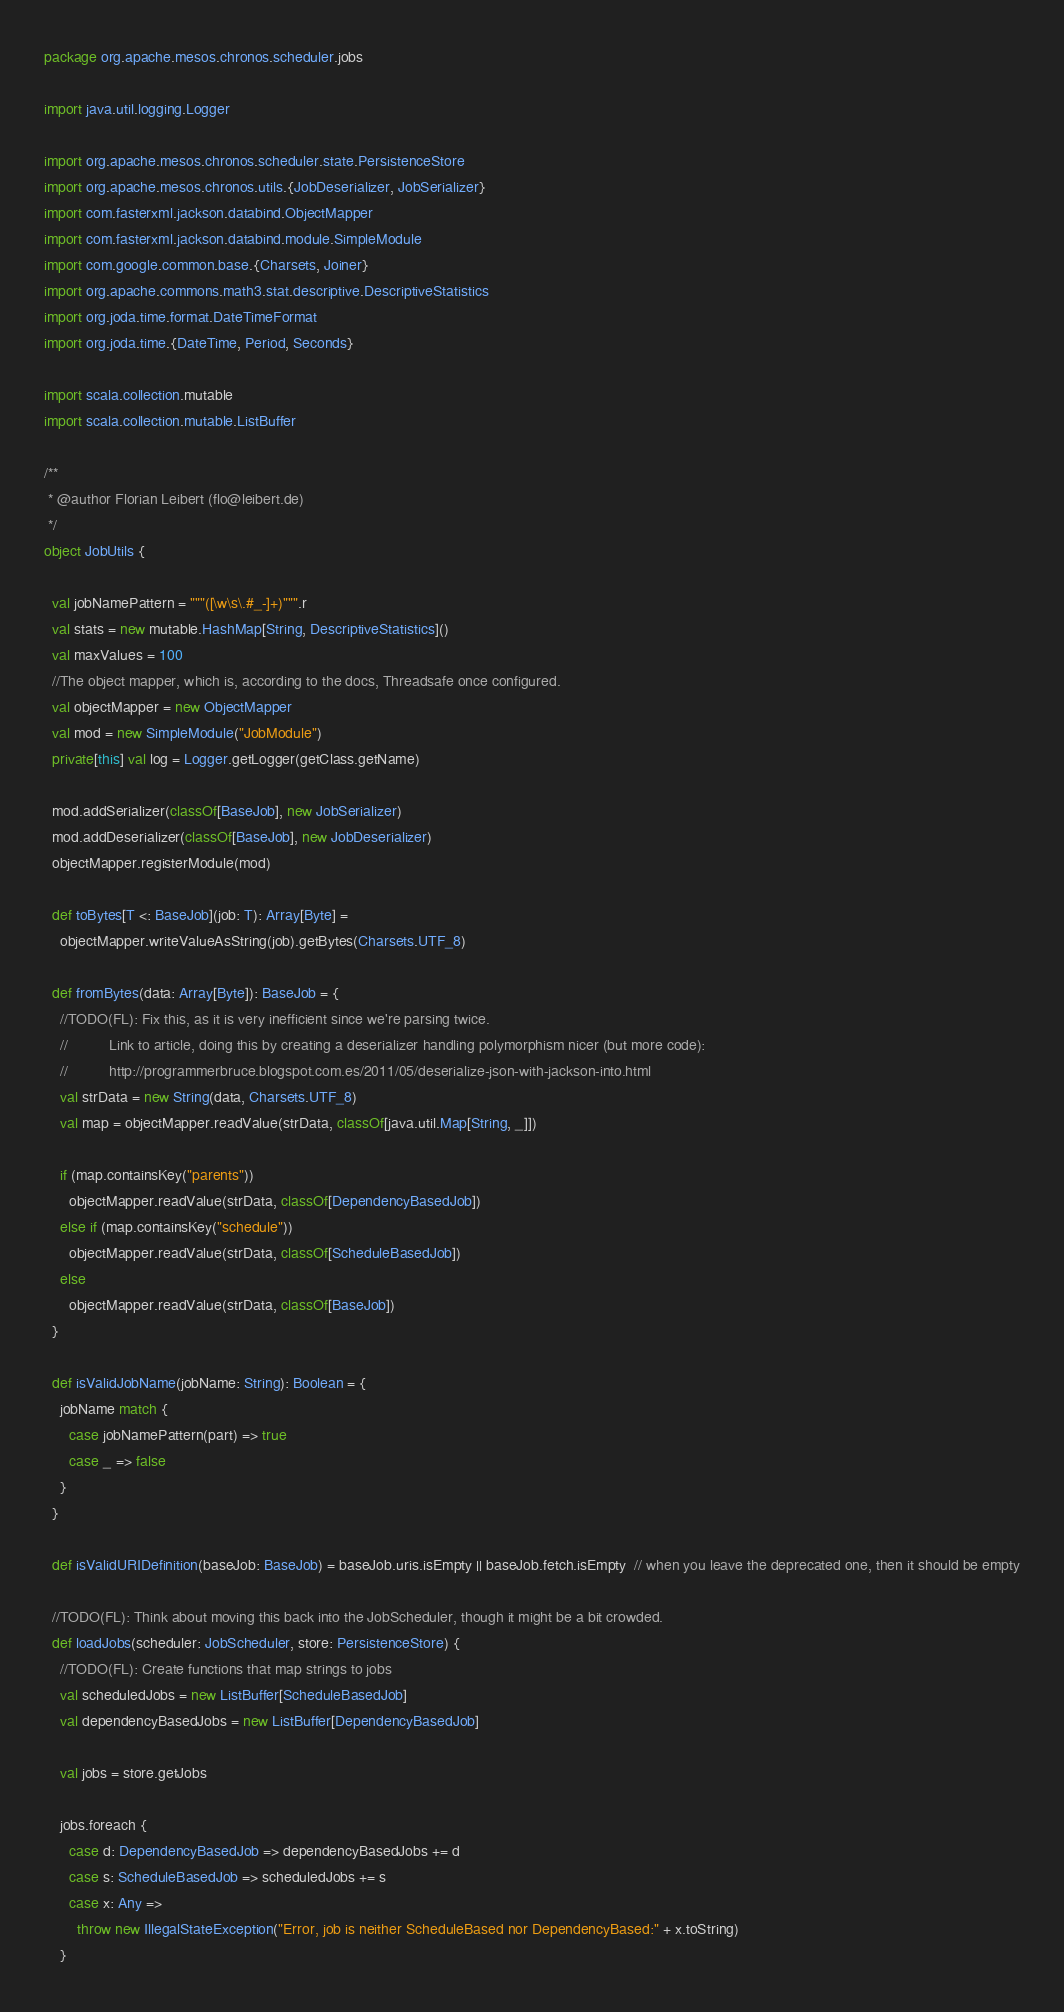Convert code to text. <code><loc_0><loc_0><loc_500><loc_500><_Scala_>package org.apache.mesos.chronos.scheduler.jobs

import java.util.logging.Logger

import org.apache.mesos.chronos.scheduler.state.PersistenceStore
import org.apache.mesos.chronos.utils.{JobDeserializer, JobSerializer}
import com.fasterxml.jackson.databind.ObjectMapper
import com.fasterxml.jackson.databind.module.SimpleModule
import com.google.common.base.{Charsets, Joiner}
import org.apache.commons.math3.stat.descriptive.DescriptiveStatistics
import org.joda.time.format.DateTimeFormat
import org.joda.time.{DateTime, Period, Seconds}

import scala.collection.mutable
import scala.collection.mutable.ListBuffer

/**
 * @author Florian Leibert (flo@leibert.de)
 */
object JobUtils {

  val jobNamePattern = """([\w\s\.#_-]+)""".r
  val stats = new mutable.HashMap[String, DescriptiveStatistics]()
  val maxValues = 100
  //The object mapper, which is, according to the docs, Threadsafe once configured.
  val objectMapper = new ObjectMapper
  val mod = new SimpleModule("JobModule")
  private[this] val log = Logger.getLogger(getClass.getName)

  mod.addSerializer(classOf[BaseJob], new JobSerializer)
  mod.addDeserializer(classOf[BaseJob], new JobDeserializer)
  objectMapper.registerModule(mod)

  def toBytes[T <: BaseJob](job: T): Array[Byte] =
    objectMapper.writeValueAsString(job).getBytes(Charsets.UTF_8)

  def fromBytes(data: Array[Byte]): BaseJob = {
    //TODO(FL): Fix this, as it is very inefficient since we're parsing twice.
    //          Link to article, doing this by creating a deserializer handling polymorphism nicer (but more code):
    //          http://programmerbruce.blogspot.com.es/2011/05/deserialize-json-with-jackson-into.html
    val strData = new String(data, Charsets.UTF_8)
    val map = objectMapper.readValue(strData, classOf[java.util.Map[String, _]])

    if (map.containsKey("parents"))
      objectMapper.readValue(strData, classOf[DependencyBasedJob])
    else if (map.containsKey("schedule"))
      objectMapper.readValue(strData, classOf[ScheduleBasedJob])
    else
      objectMapper.readValue(strData, classOf[BaseJob])
  }

  def isValidJobName(jobName: String): Boolean = {
    jobName match {
      case jobNamePattern(part) => true
      case _ => false
    }
  }

  def isValidURIDefinition(baseJob: BaseJob) = baseJob.uris.isEmpty || baseJob.fetch.isEmpty  // when you leave the deprecated one, then it should be empty

  //TODO(FL): Think about moving this back into the JobScheduler, though it might be a bit crowded.
  def loadJobs(scheduler: JobScheduler, store: PersistenceStore) {
    //TODO(FL): Create functions that map strings to jobs
    val scheduledJobs = new ListBuffer[ScheduleBasedJob]
    val dependencyBasedJobs = new ListBuffer[DependencyBasedJob]

    val jobs = store.getJobs

    jobs.foreach {
      case d: DependencyBasedJob => dependencyBasedJobs += d
      case s: ScheduleBasedJob => scheduledJobs += s
      case x: Any =>
        throw new IllegalStateException("Error, job is neither ScheduleBased nor DependencyBased:" + x.toString)
    }
</code> 